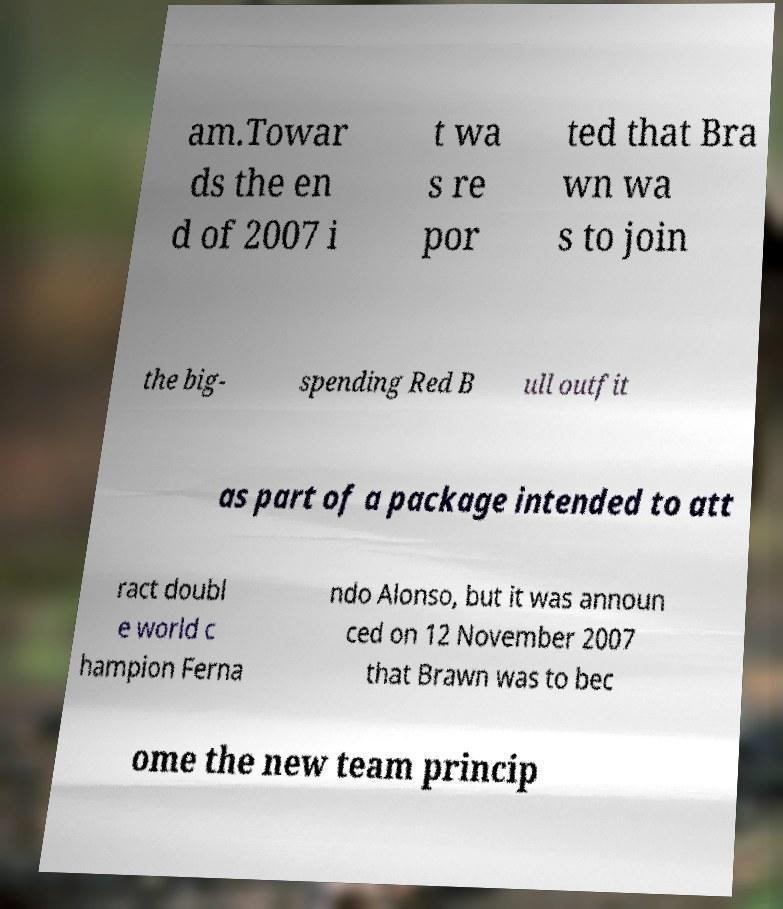There's text embedded in this image that I need extracted. Can you transcribe it verbatim? am.Towar ds the en d of 2007 i t wa s re por ted that Bra wn wa s to join the big- spending Red B ull outfit as part of a package intended to att ract doubl e world c hampion Ferna ndo Alonso, but it was announ ced on 12 November 2007 that Brawn was to bec ome the new team princip 